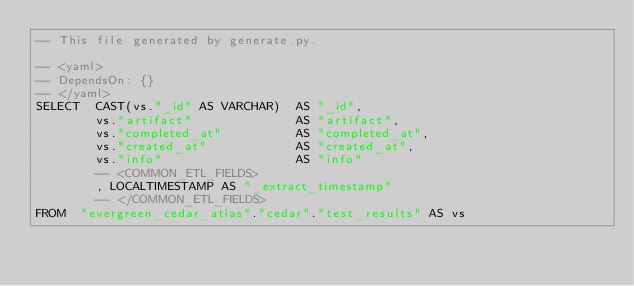<code> <loc_0><loc_0><loc_500><loc_500><_SQL_>-- This file generated by generate.py.

-- <yaml>
-- DependsOn: {}
-- </yaml>
SELECT  CAST(vs."_id" AS VARCHAR)  AS "_id",
        vs."artifact"              AS "artifact",
        vs."completed_at"          AS "completed_at",
        vs."created_at"            AS "created_at",
        vs."info"                  AS "info"
        -- <COMMON_ETL_FIELDS>
        , LOCALTIMESTAMP AS "_extract_timestamp"
        -- </COMMON_ETL_FIELDS>
FROM  "evergreen_cedar_atlas"."cedar"."test_results" AS vs

</code> 